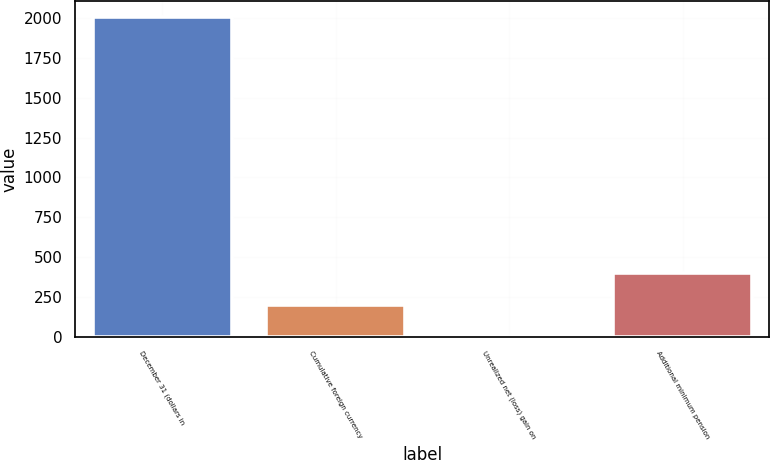Convert chart. <chart><loc_0><loc_0><loc_500><loc_500><bar_chart><fcel>December 31 (dollars in<fcel>Cumulative foreign currency<fcel>Unrealized net (loss) gain on<fcel>Additional minimum pension<nl><fcel>2007<fcel>201.33<fcel>0.7<fcel>401.96<nl></chart> 